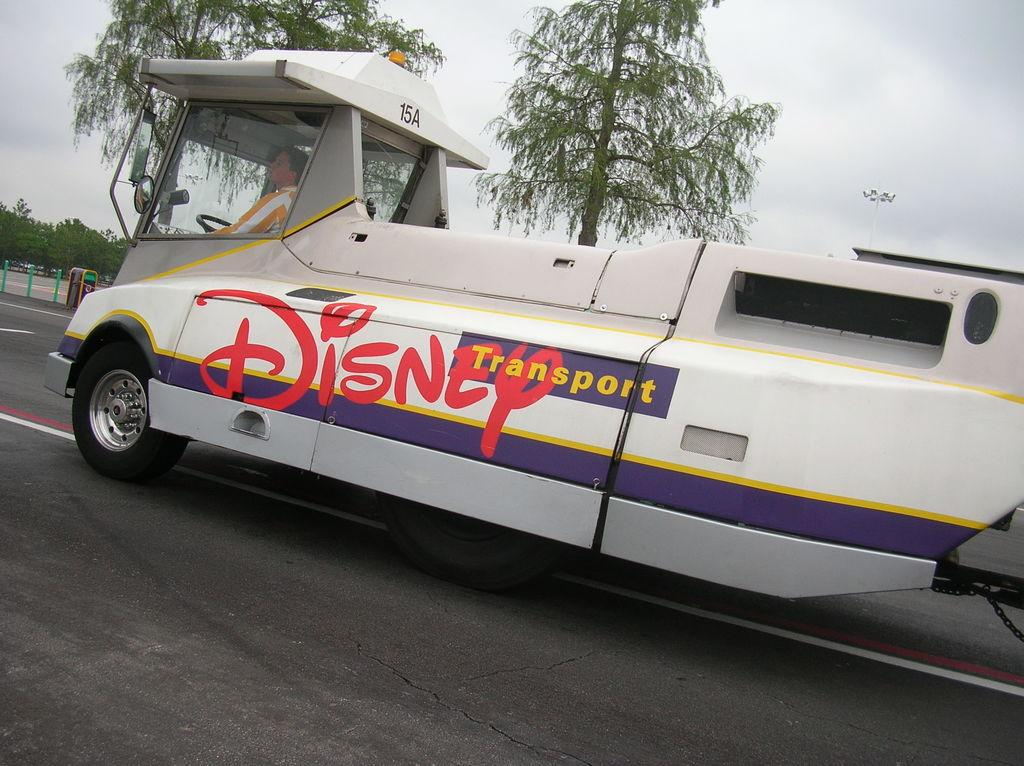What is on the road in the image? There is a vehicle on the road in the image. Who is inside the vehicle? A person is sitting in the vehicle. What can be seen in the background of the image? There are trees and the sky visible in the background of the image. What is at the bottom of the image? There is a road at the bottom of the image. What type of coal is being transported by the person in the vehicle? There is no coal present in the image, and the person is sitting in the vehicle, not transporting anything. 